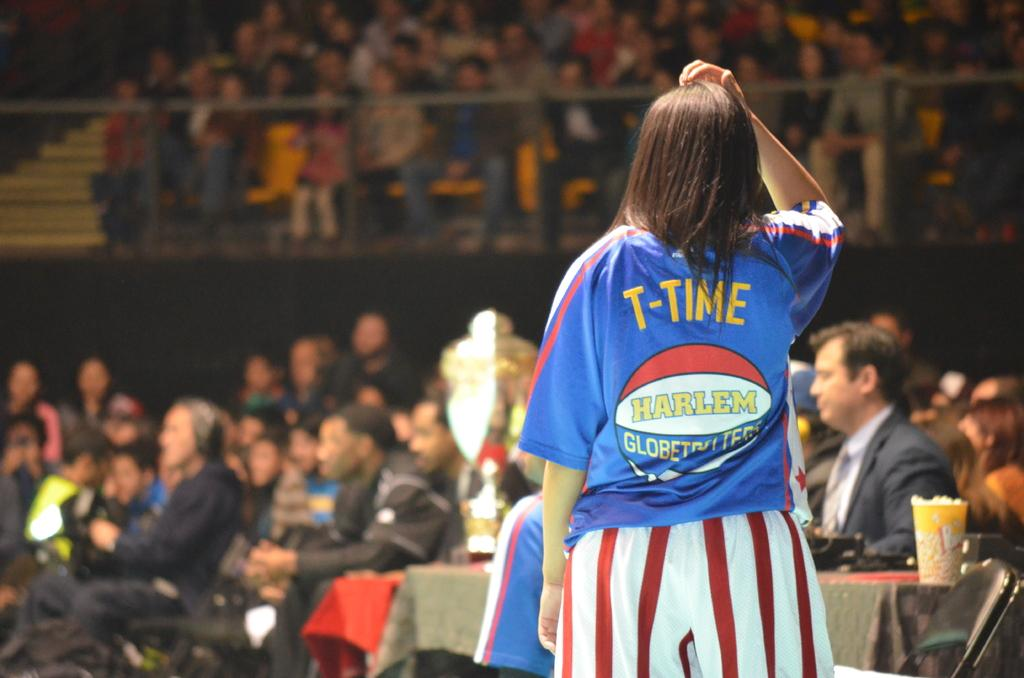<image>
Provide a brief description of the given image. A person in a blue shirt with T-time on the back is in front of an audience. 